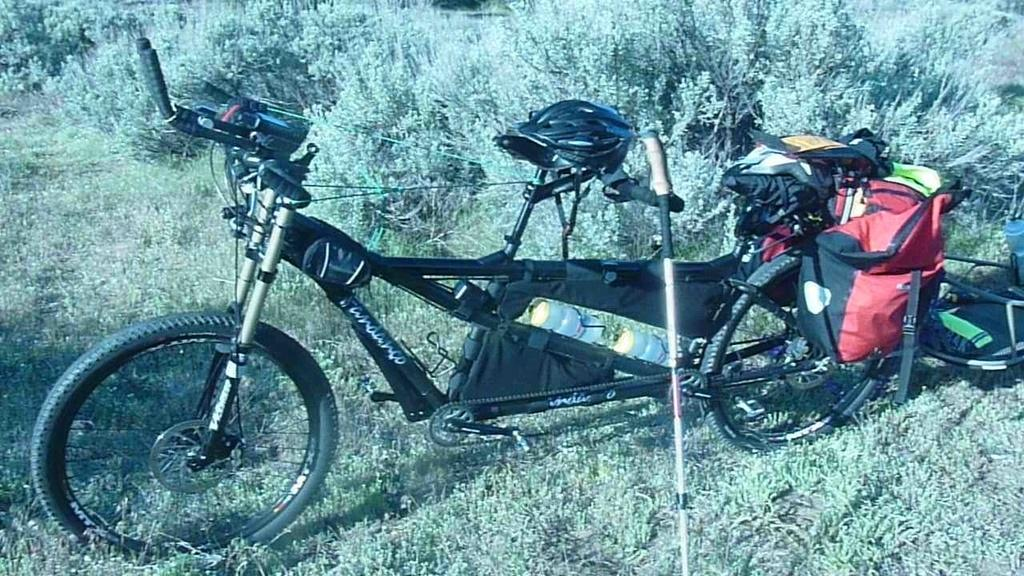What type of bicycle is in the image? There is a tandem bicycle in the image. What is attached to the tandem bicycle? The tandem bicycle has luggage attached to it, and a trolley is also attached to it. Where are the tandem bicycle, luggage, and trolley located? They are on the surface of the grass. What type of baseball equipment can be seen near the tandem bicycle? There is no baseball equipment present in the image. Can you tell me how many wrenches are attached to the tandem bicycle? There are no wrenches attached to the tandem bicycle in the image. 